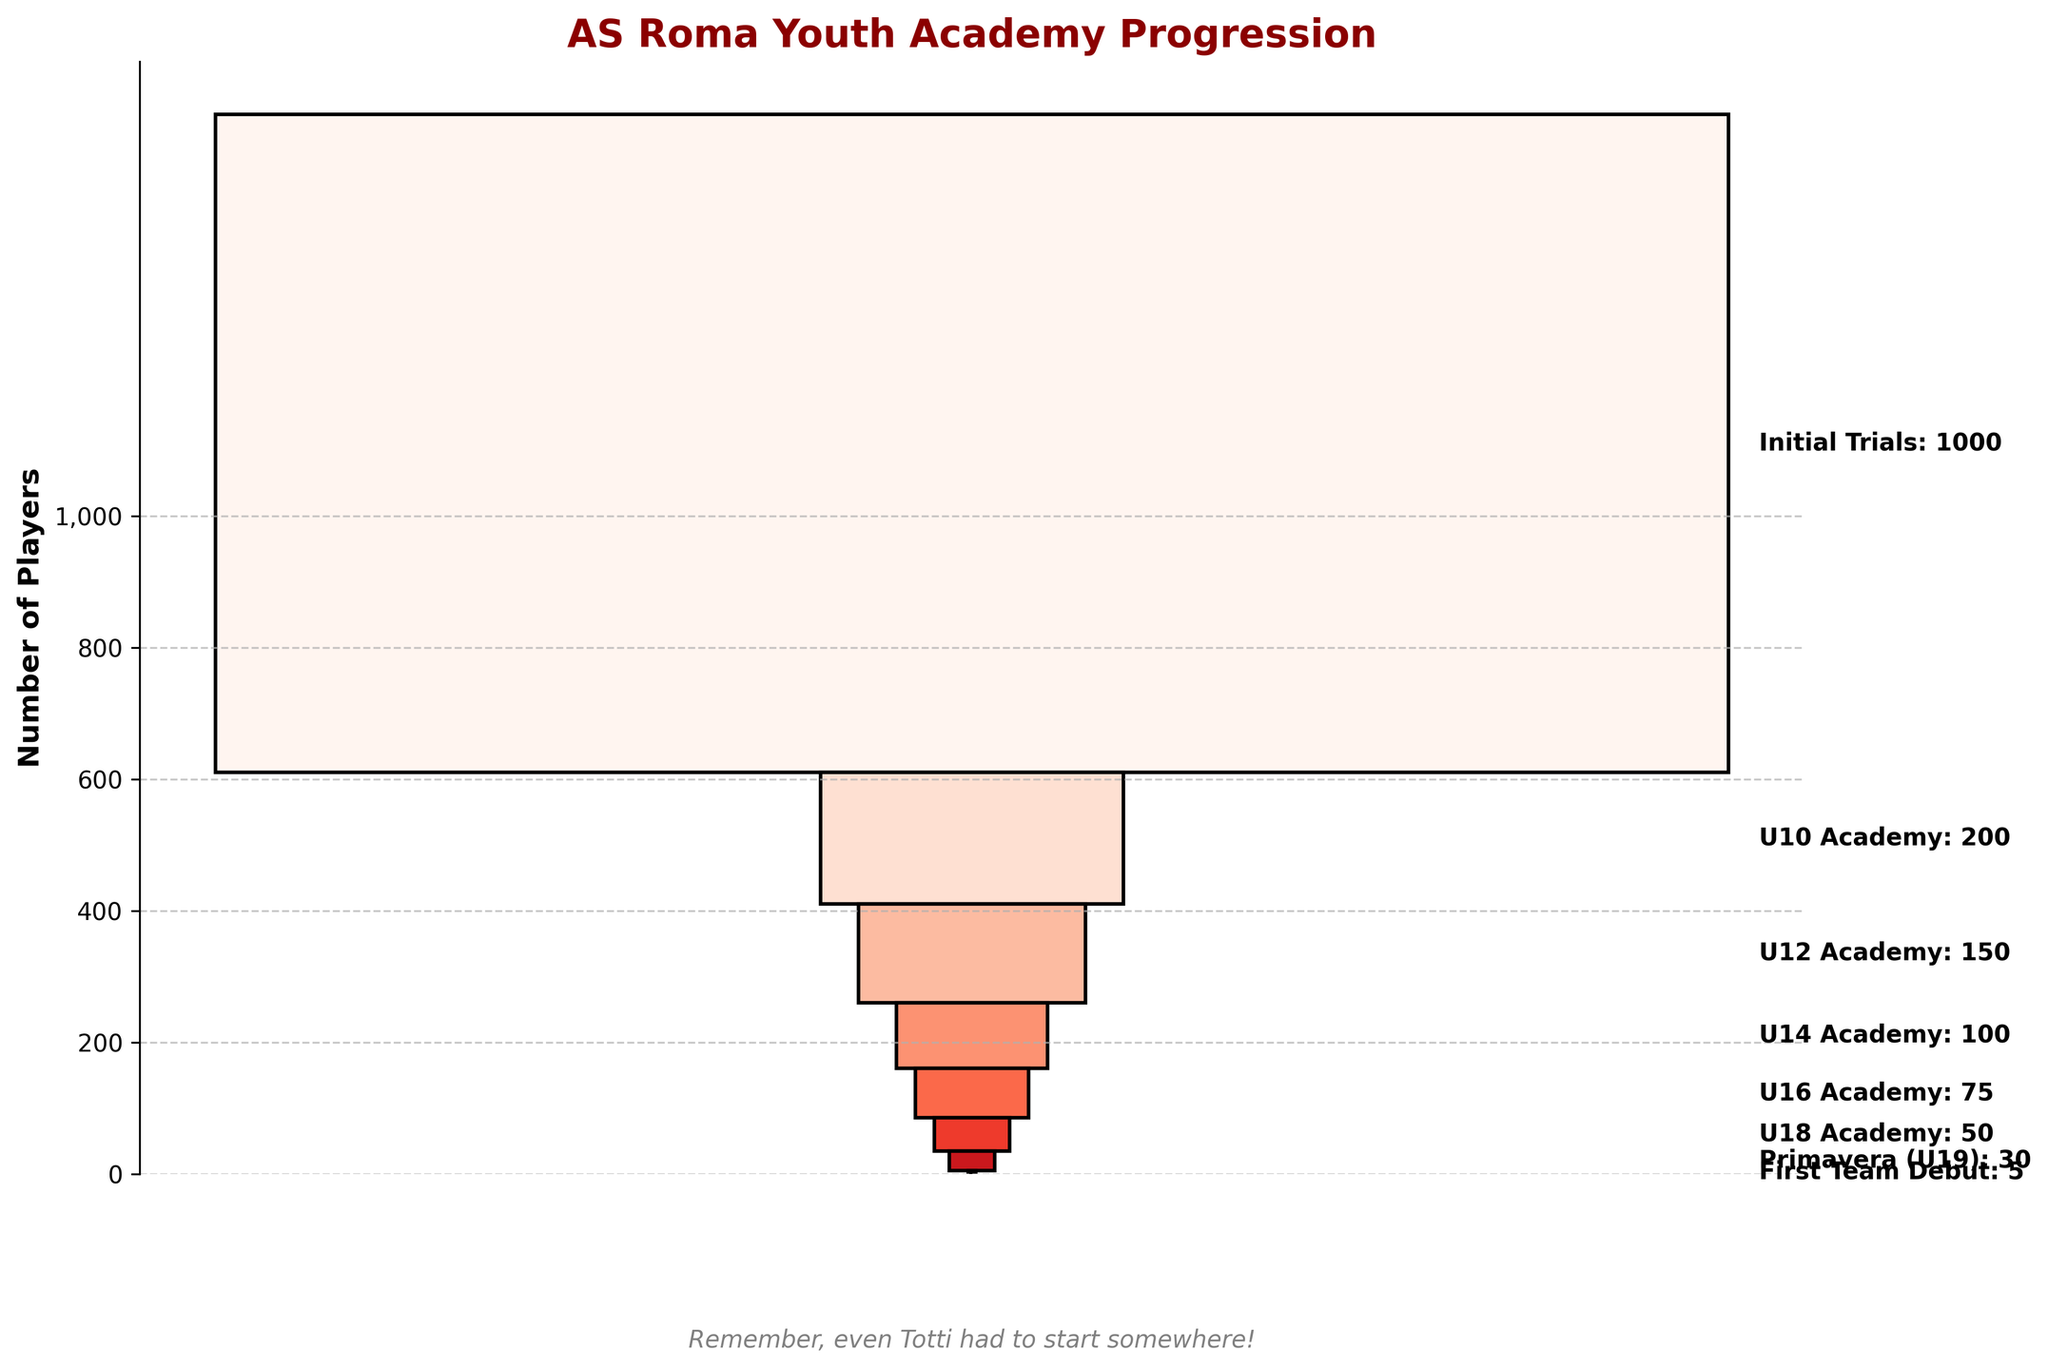What's the title of the figure? The title of the figure is usually located at the top of the chart and provides a brief description of what the chart is about.
Answer: AS Roma Youth Academy Progression How many players made it to the U18 Academy? Check the label corresponding to the U18 Academy stage to find the number of players.
Answer: 50 Which stage has the highest number of players? Look for the stage with the widest bar at the bottom of the funnel.
Answer: Initial Trials How many players moved from U14 Academy to U16 Academy? Subtract the number of players in U16 Academy from the number of players in U14 Academy.
Answer: 100 - 75 = 25 What is the total number of players from the U10 Academy to the U16 Academy? Sum the number of players in U10 Academy, U12 Academy, U14 Academy, and U16 Academy.
Answer: 200 + 150 + 100 + 75 = 525 Which stage has the least number of players? Identify the narrowest bar at the top of the funnel chart.
Answer: First Team Debut How does the number of players in the U12 Academy compare to the number in the Primavera (U19)? Compare the number of players in U12 Academy with those in Primavera (U19).
Answer: U12 Academy has more players What percentage of players from the Initial Trials reached the First Team Debut? Divide the number of players in the First Team Debut by the number in Initial Trials, then multiply by 100.
Answer: (5 / 1000) * 100 = 0.5% By how much does the number of players decrease from the U10 Academy to the U18 Academy? Subtract the number of players in the U18 Academy from the number in the U10 Academy.
Answer: 200 - 50 = 150 What is the ratio of players in the U14 Academy to those in the U16 Academy? Divide the number of players in U14 Academy by the number in U16 Academy.
Answer: 100 / 75 = 1.33 